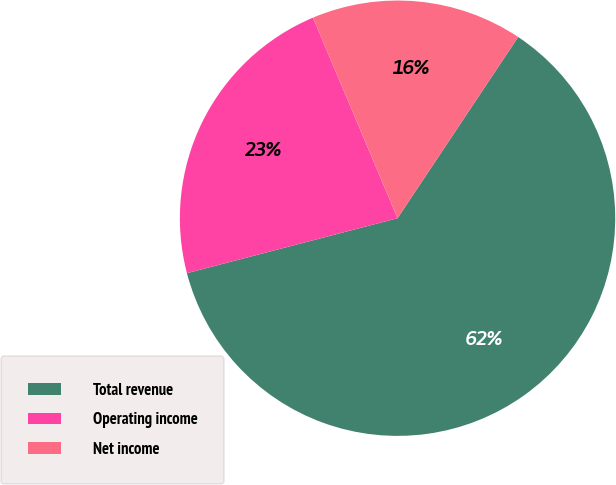<chart> <loc_0><loc_0><loc_500><loc_500><pie_chart><fcel>Total revenue<fcel>Operating income<fcel>Net income<nl><fcel>61.59%<fcel>22.71%<fcel>15.7%<nl></chart> 